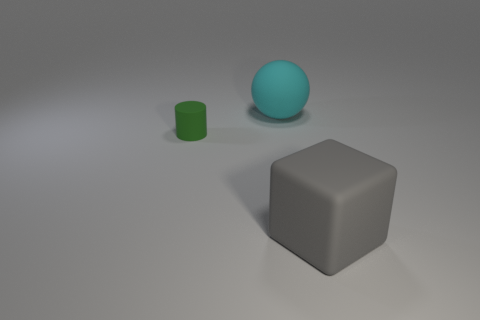What emotions or atmosphere does the composition of this image evoke? The composition of the image evokes a sense of minimalism and calmness. The muted colors, the simplicity of the shapes, and the soft, diffused lighting contribute to an atmosphere of tranquility and order. It could also be perceived as a bit stark or sterile, given the lack of context or other elements in the scene. 